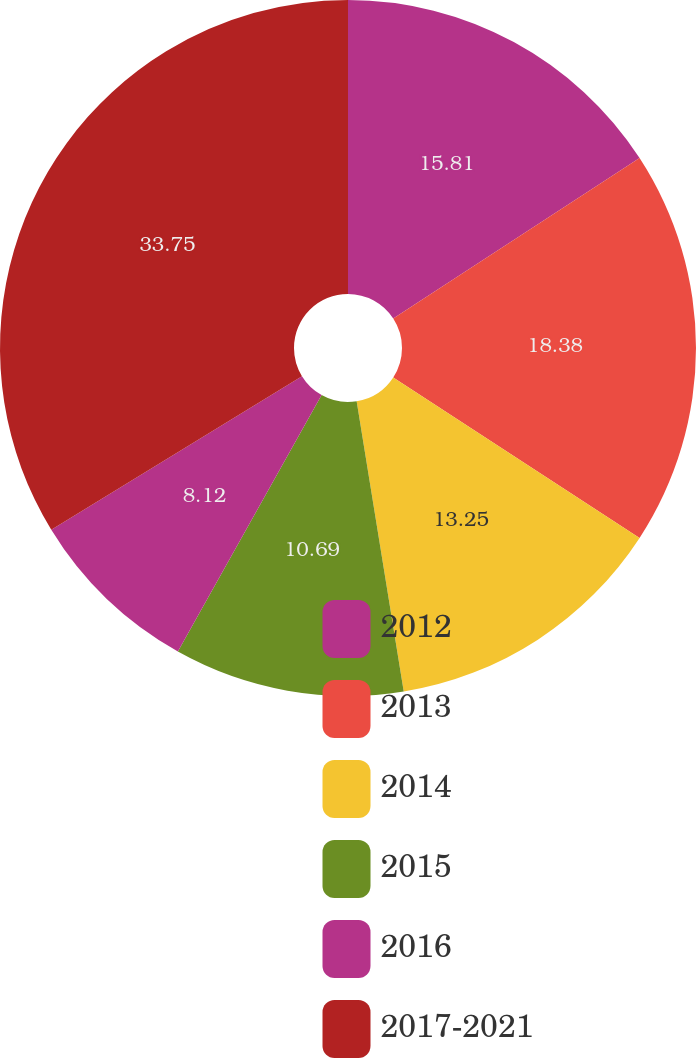<chart> <loc_0><loc_0><loc_500><loc_500><pie_chart><fcel>2012<fcel>2013<fcel>2014<fcel>2015<fcel>2016<fcel>2017-2021<nl><fcel>15.81%<fcel>18.38%<fcel>13.25%<fcel>10.69%<fcel>8.12%<fcel>33.75%<nl></chart> 